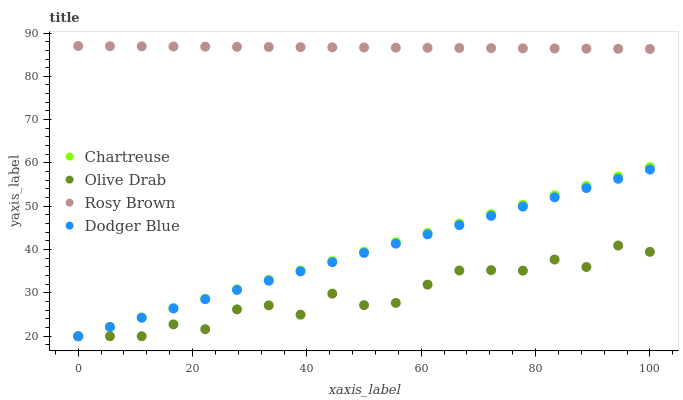Does Olive Drab have the minimum area under the curve?
Answer yes or no. Yes. Does Rosy Brown have the maximum area under the curve?
Answer yes or no. Yes. Does Dodger Blue have the minimum area under the curve?
Answer yes or no. No. Does Dodger Blue have the maximum area under the curve?
Answer yes or no. No. Is Chartreuse the smoothest?
Answer yes or no. Yes. Is Olive Drab the roughest?
Answer yes or no. Yes. Is Rosy Brown the smoothest?
Answer yes or no. No. Is Rosy Brown the roughest?
Answer yes or no. No. Does Chartreuse have the lowest value?
Answer yes or no. Yes. Does Rosy Brown have the lowest value?
Answer yes or no. No. Does Rosy Brown have the highest value?
Answer yes or no. Yes. Does Dodger Blue have the highest value?
Answer yes or no. No. Is Olive Drab less than Rosy Brown?
Answer yes or no. Yes. Is Rosy Brown greater than Dodger Blue?
Answer yes or no. Yes. Does Chartreuse intersect Dodger Blue?
Answer yes or no. Yes. Is Chartreuse less than Dodger Blue?
Answer yes or no. No. Is Chartreuse greater than Dodger Blue?
Answer yes or no. No. Does Olive Drab intersect Rosy Brown?
Answer yes or no. No. 